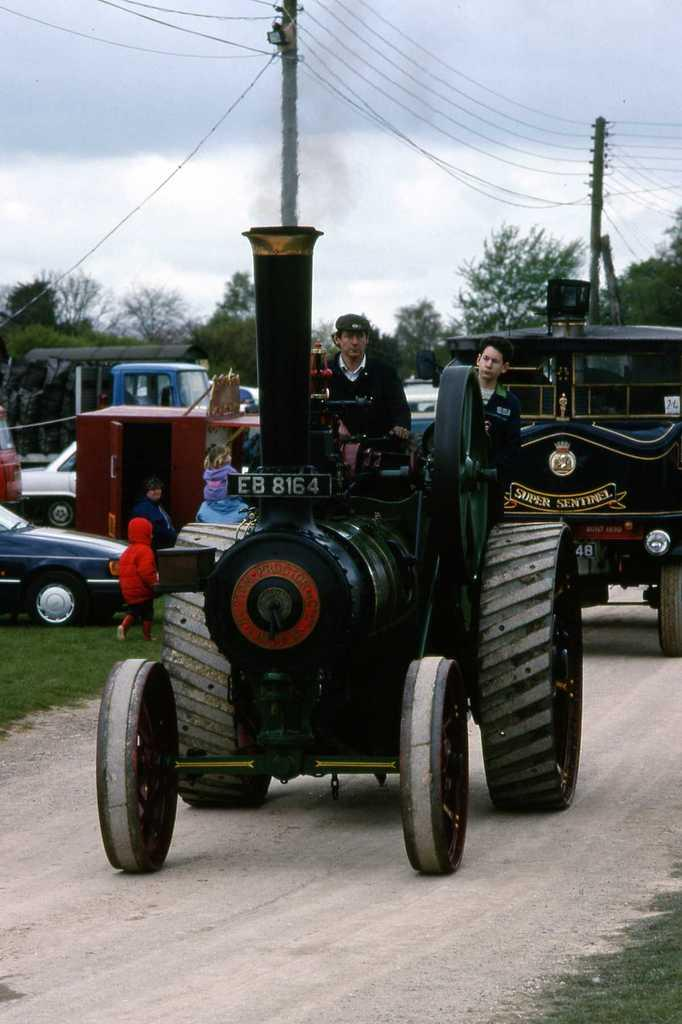What can be seen in the image? There are vehicles in the image, and people are sitting in them. What is visible in the background of the image? Trees, wires, poles, and the sky are visible in the background of the image. Where are the kids located in the image? The kids are on the left side of the image. What is the aftermath of the earthquake in the image? There is no mention of an earthquake or its aftermath in the image. Can you describe the earth in the image? The image does not show the earth as a planet or any specific geological features; it depicts a scene with vehicles, people, and background elements. 